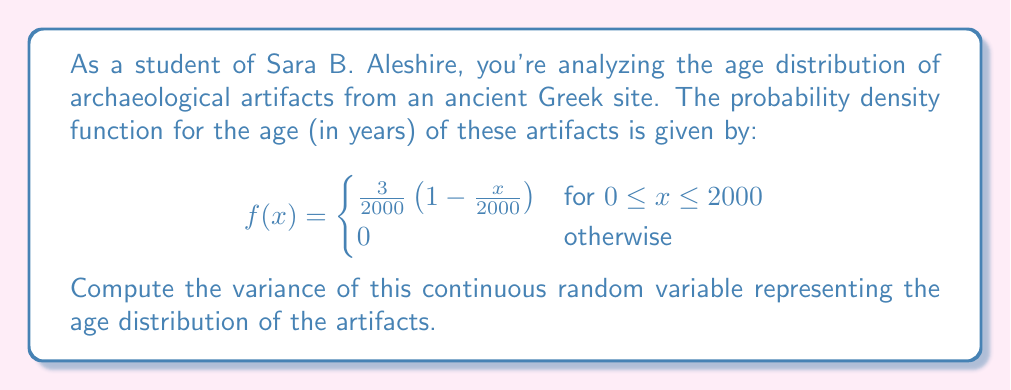Show me your answer to this math problem. To compute the variance, we need to follow these steps:

1. Calculate the expected value (mean) $E[X]$:
   $$E[X] = \int_0^{2000} x \cdot \frac{3}{2000}(1-\frac{x}{2000}) dx$$

2. Calculate $E[X^2]$:
   $$E[X^2] = \int_0^{2000} x^2 \cdot \frac{3}{2000}(1-\frac{x}{2000}) dx$$

3. Use the variance formula: $Var(X) = E[X^2] - (E[X])^2$

Step 1: Calculating $E[X]$
$$\begin{align}
E[X] &= \int_0^{2000} x \cdot \frac{3}{2000}(1-\frac{x}{2000}) dx \\
&= \frac{3}{2000} \int_0^{2000} (x - \frac{x^2}{2000}) dx \\
&= \frac{3}{2000} [\frac{x^2}{2} - \frac{x^3}{6000}]_0^{2000} \\
&= \frac{3}{2000} [2000000 - \frac{8000000000}{6000}] \\
&= \frac{3}{2000} [2000000 - 1333333.33] \\
&= \frac{3}{2000} \cdot 666666.67 \\
&= 1000
\end{align}$$

Step 2: Calculating $E[X^2]$
$$\begin{align}
E[X^2] &= \int_0^{2000} x^2 \cdot \frac{3}{2000}(1-\frac{x}{2000}) dx \\
&= \frac{3}{2000} \int_0^{2000} (x^2 - \frac{x^3}{2000}) dx \\
&= \frac{3}{2000} [\frac{x^3}{3} - \frac{x^4}{8000}]_0^{2000} \\
&= \frac{3}{2000} [2666666.67 - 1000000] \\
&= \frac{3}{2000} \cdot 1666666.67 \\
&= 2500000
\end{align}$$

Step 3: Calculating $Var(X)$
$$\begin{align}
Var(X) &= E[X^2] - (E[X])^2 \\
&= 2500000 - 1000^2 \\
&= 2500000 - 1000000 \\
&= 1500000
\end{align}$$

Therefore, the variance of the age distribution is 1,500,000 years².
Answer: 1,500,000 years² 